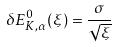<formula> <loc_0><loc_0><loc_500><loc_500>\delta E _ { { K } , \alpha } ^ { 0 } ( \xi ) = \frac { \sigma } { \sqrt { \xi } }</formula> 